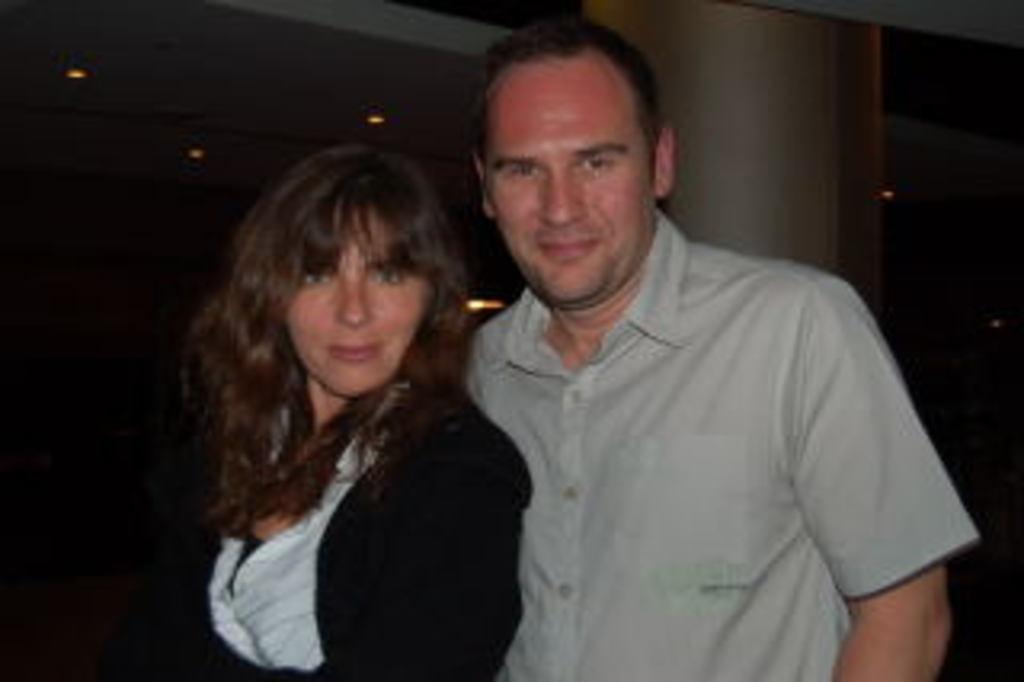Please provide a concise description of this image. In this picture we can see there are two people standing and behind the people there is a pillar and at the top there are ceiling lights. 